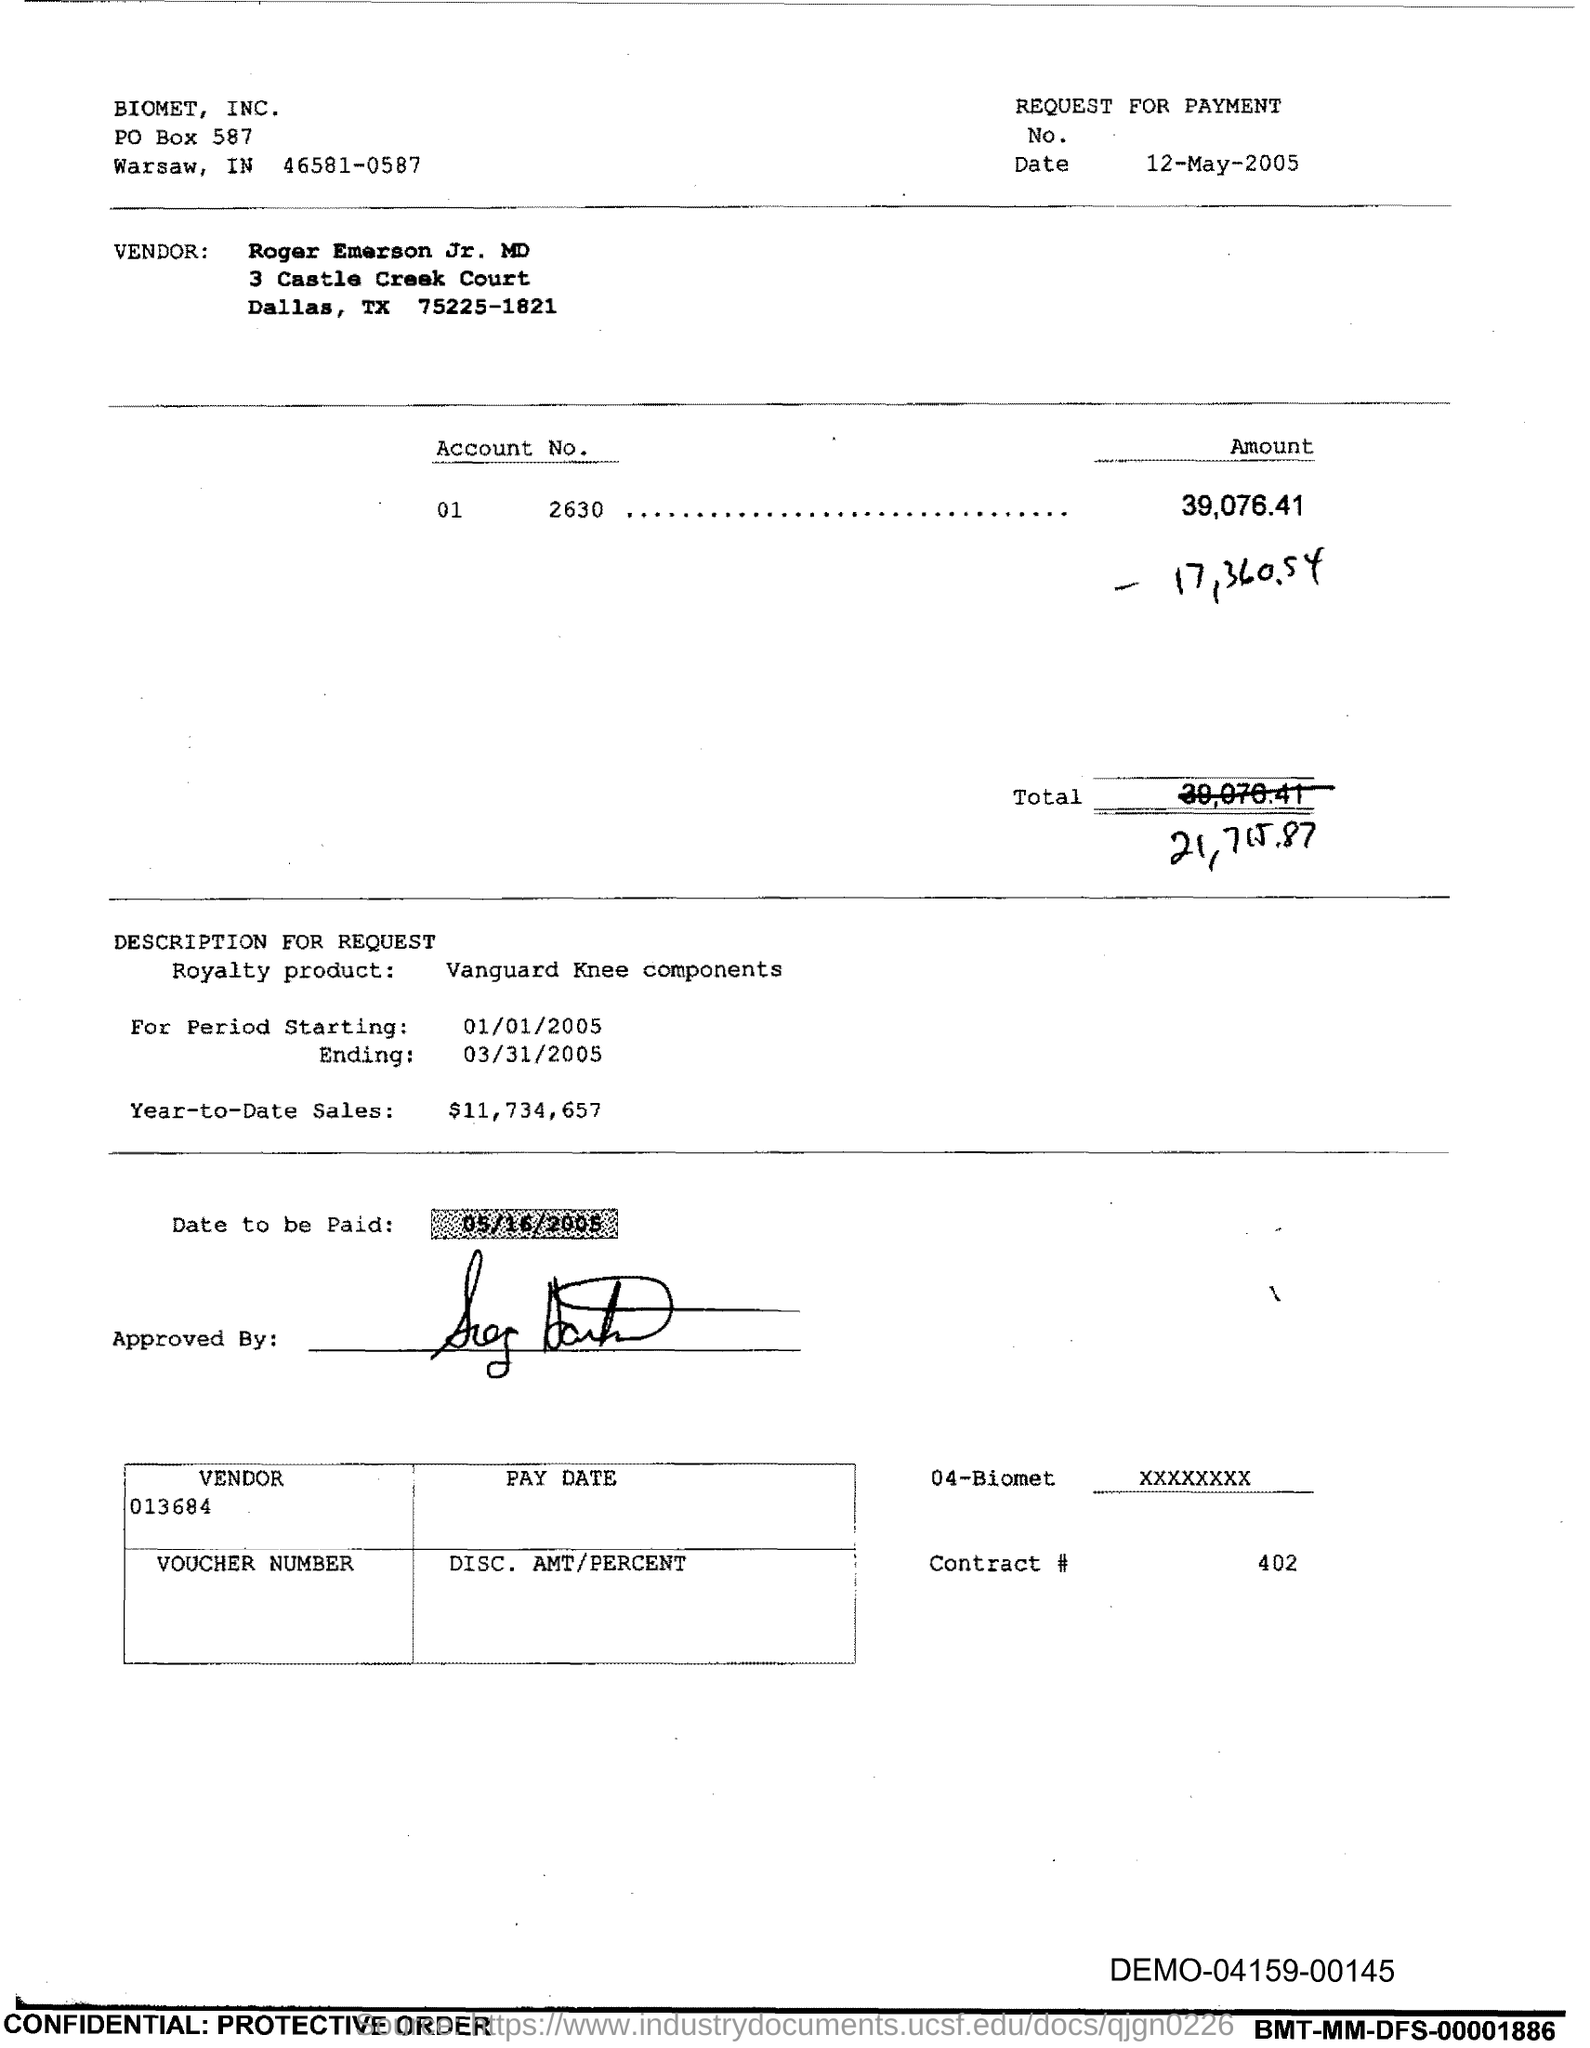What is the issued date of this voucher?
Provide a succinct answer. 12-May-2005. Who is the vendor mentioned in the voucher?
Your answer should be very brief. Roger Emerson Jr. MD. What is the Account No. given in the voucher?
Offer a very short reply. 01 2630. What is the total amount mentioned in the voucher?
Your answer should be compact. 21,715.87. What is the royalty product given in the voucher?
Your answer should be compact. Vanguard Knee components. What is the Year-to-Date Sales of the royalty product?
Your answer should be very brief. $11,734,657. What is the start date of the royalty period?
Your answer should be compact. 01/01/2005. What is the vendor number given in the voucher?
Provide a short and direct response. 013684. What is the end date of the royalty period?
Provide a succinct answer. 03/31/2005. What is the Contract # given in the voucher?
Your answer should be compact. 402. 